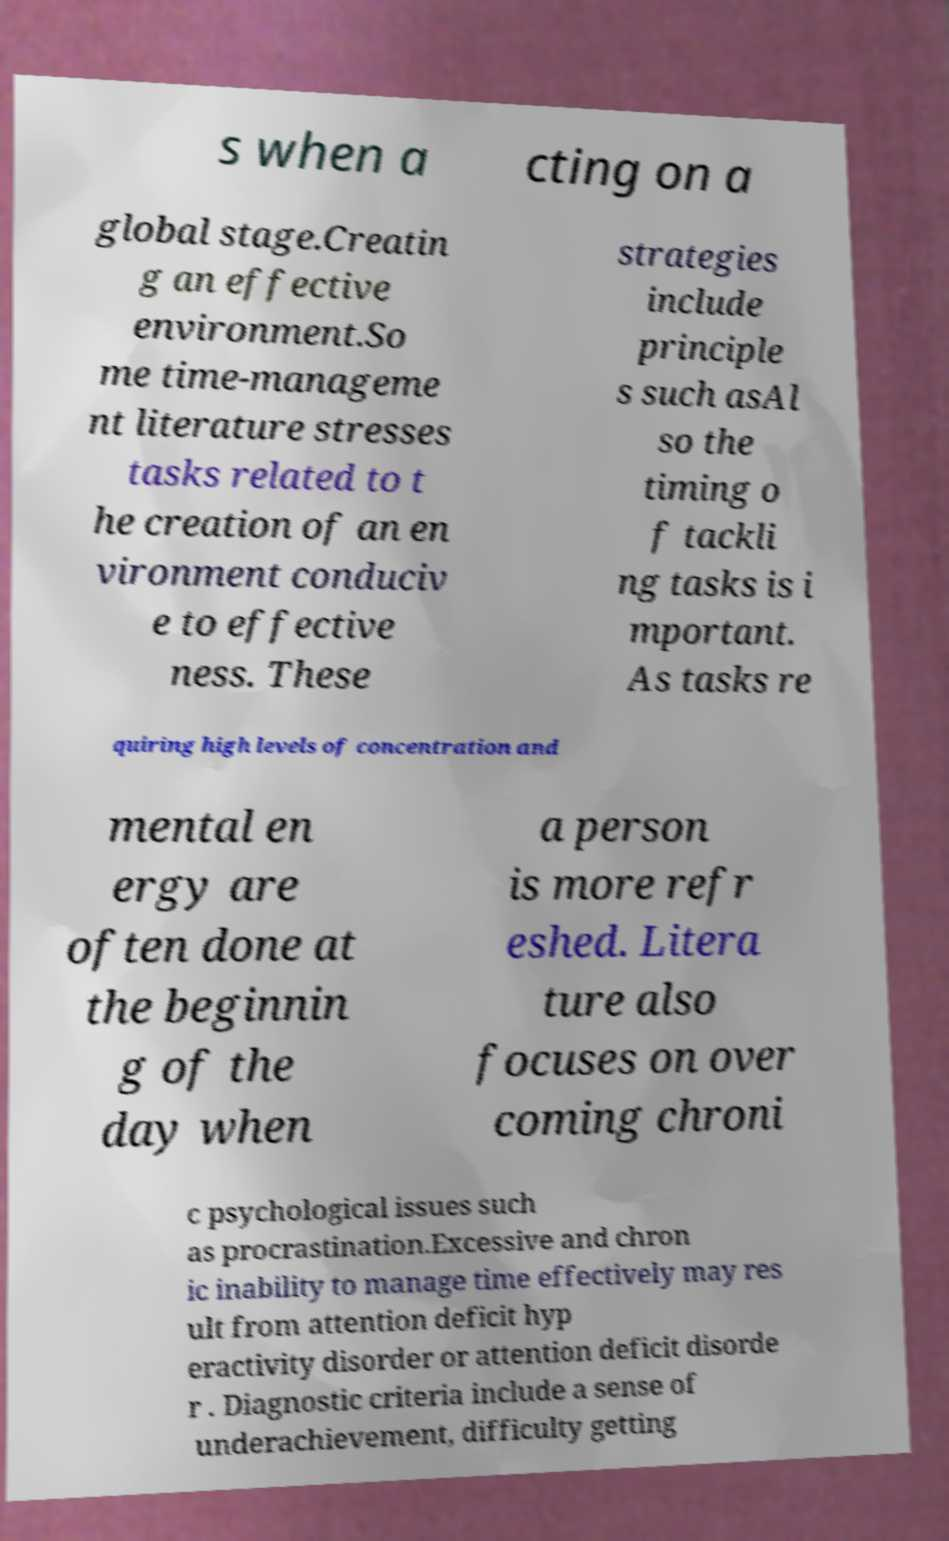Could you assist in decoding the text presented in this image and type it out clearly? s when a cting on a global stage.Creatin g an effective environment.So me time-manageme nt literature stresses tasks related to t he creation of an en vironment conduciv e to effective ness. These strategies include principle s such asAl so the timing o f tackli ng tasks is i mportant. As tasks re quiring high levels of concentration and mental en ergy are often done at the beginnin g of the day when a person is more refr eshed. Litera ture also focuses on over coming chroni c psychological issues such as procrastination.Excessive and chron ic inability to manage time effectively may res ult from attention deficit hyp eractivity disorder or attention deficit disorde r . Diagnostic criteria include a sense of underachievement, difficulty getting 